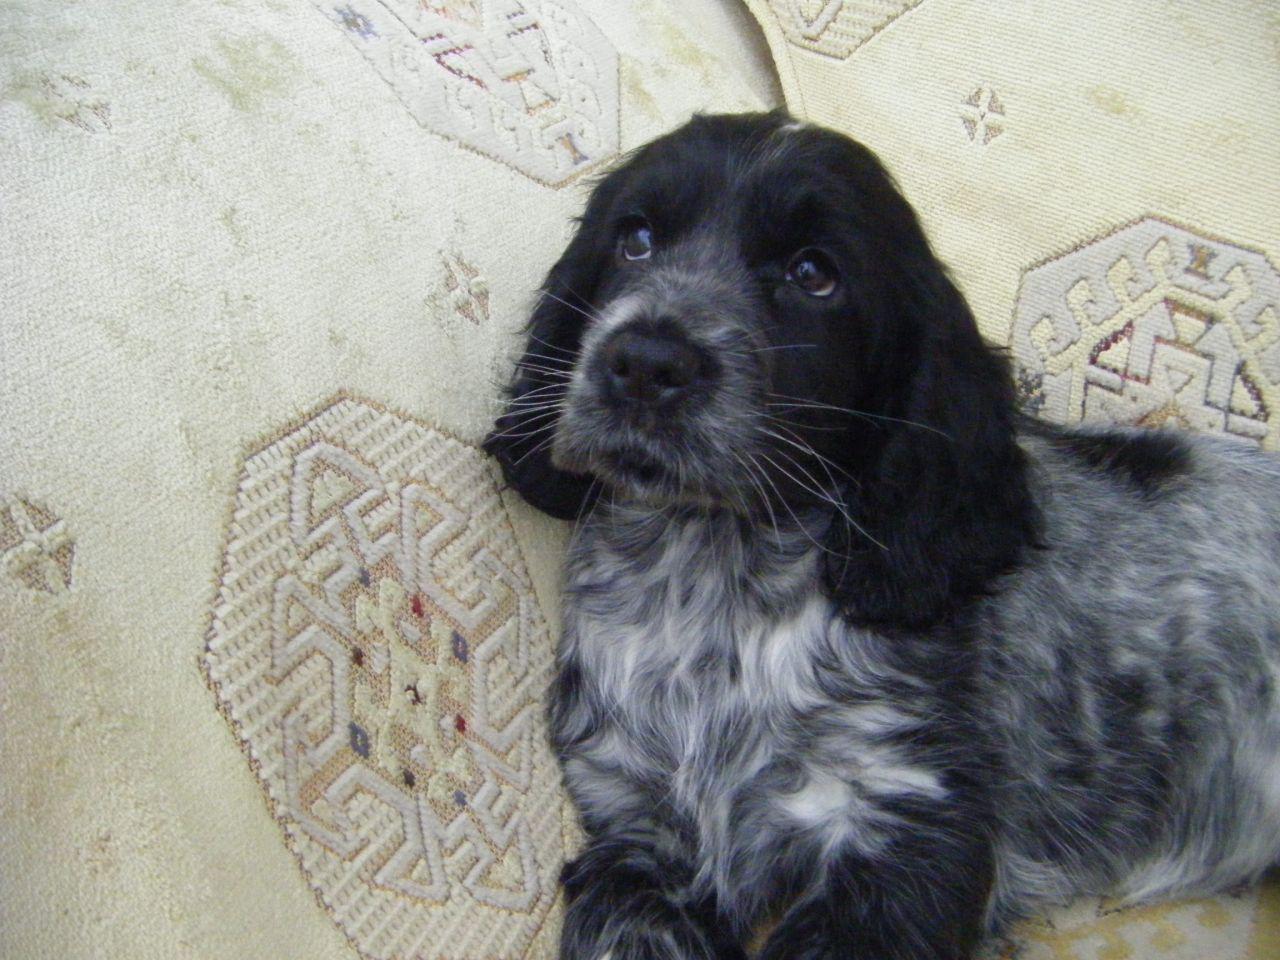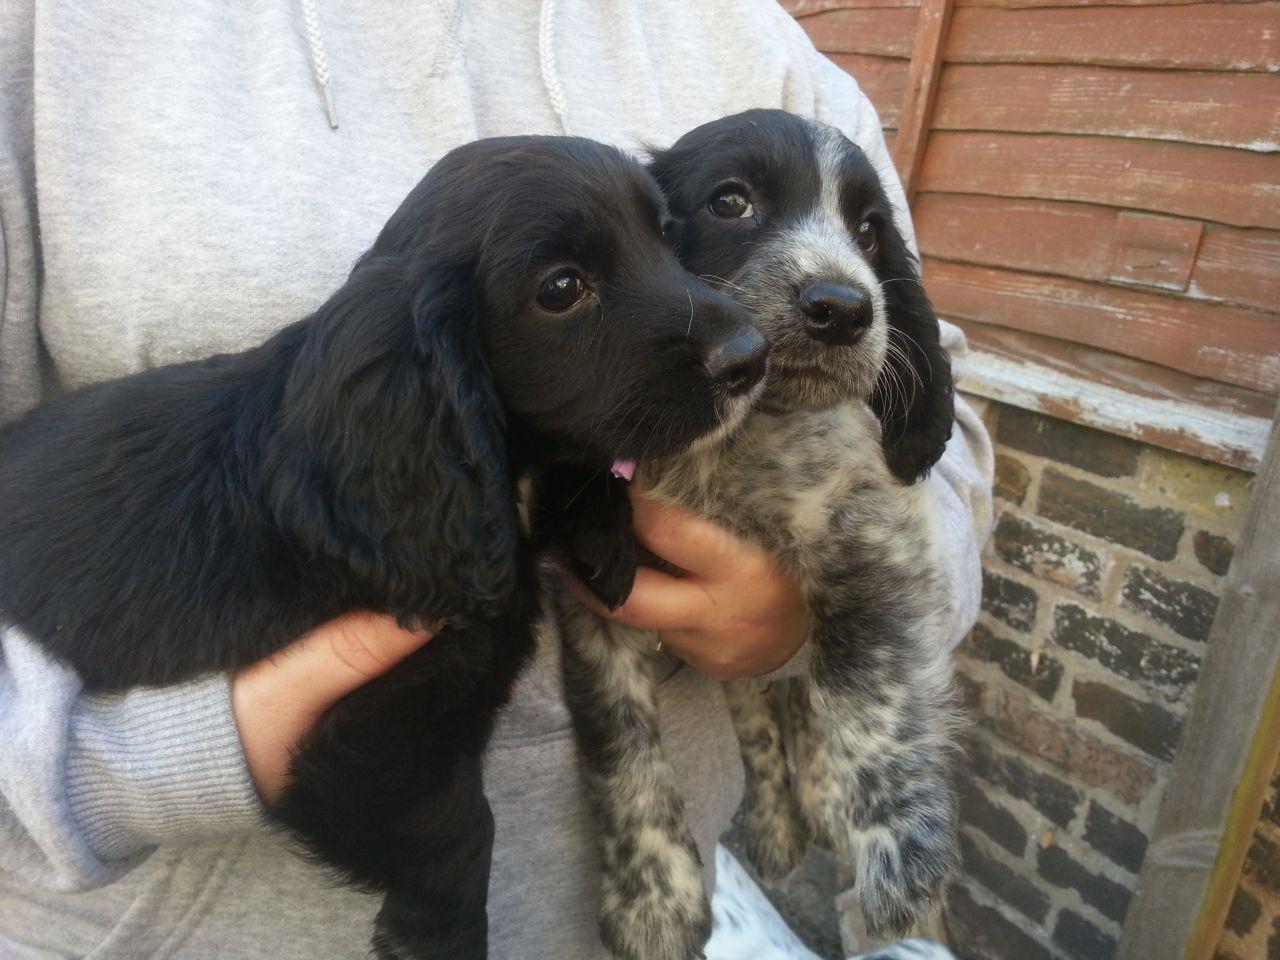The first image is the image on the left, the second image is the image on the right. Analyze the images presented: Is the assertion "The pair of images includes two dogs held by human hands." valid? Answer yes or no. Yes. 